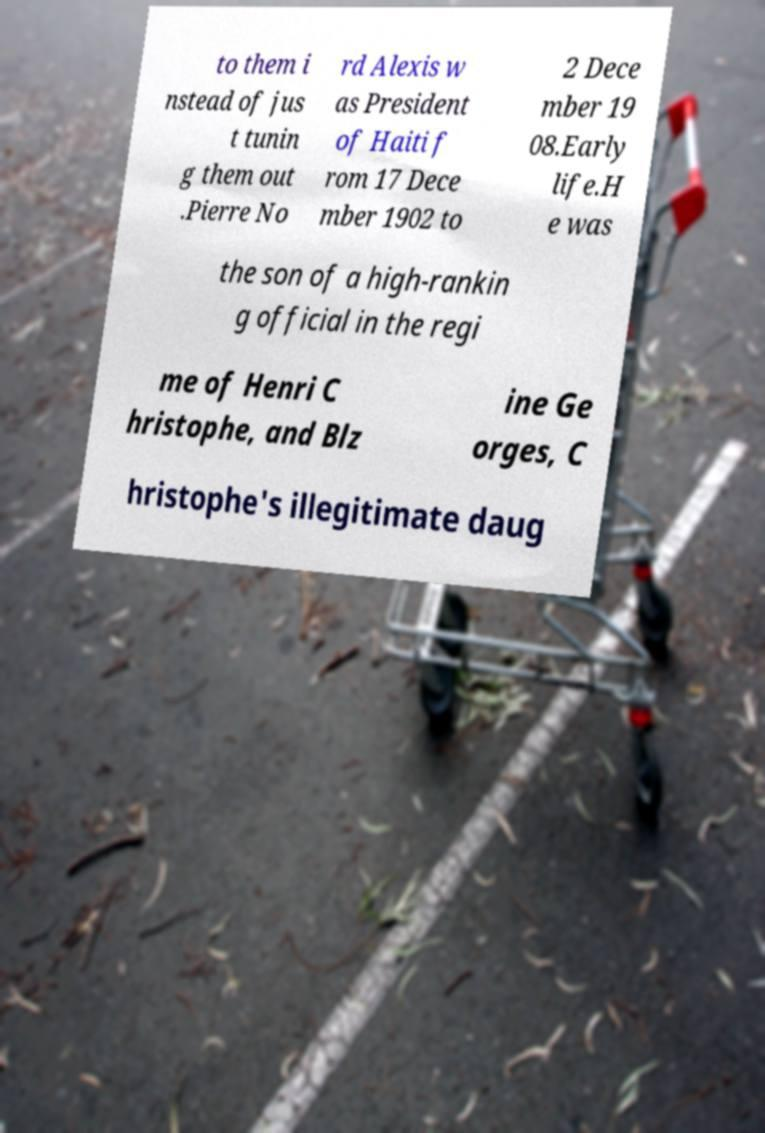Please identify and transcribe the text found in this image. to them i nstead of jus t tunin g them out .Pierre No rd Alexis w as President of Haiti f rom 17 Dece mber 1902 to 2 Dece mber 19 08.Early life.H e was the son of a high-rankin g official in the regi me of Henri C hristophe, and Blz ine Ge orges, C hristophe's illegitimate daug 